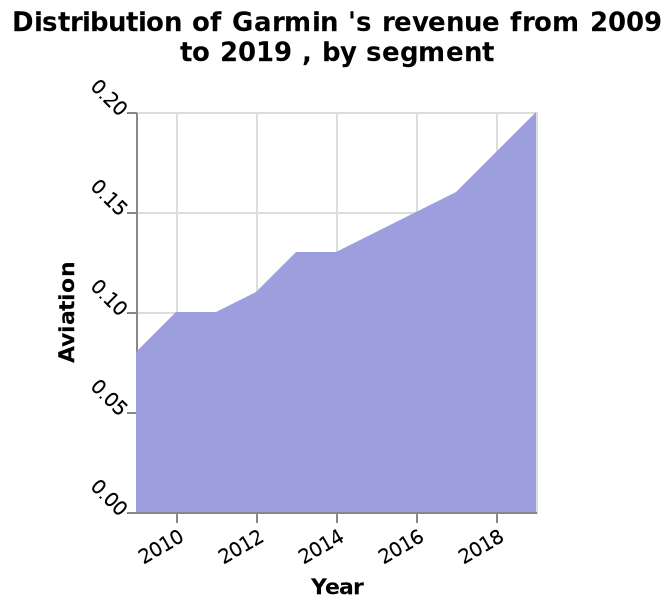<image>
What is the range of the linear scale on the y-axis? The range of the linear scale on the y-axis is from 0.00 to 0.20. 